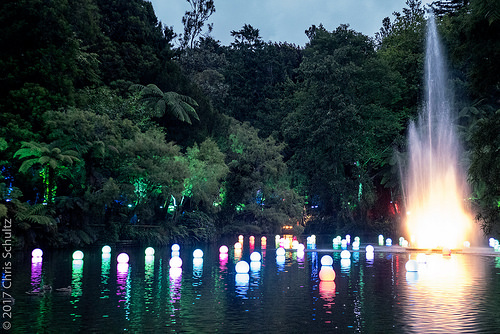<image>
Can you confirm if the light is on the water? Yes. Looking at the image, I can see the light is positioned on top of the water, with the water providing support. Is the lake under the sky? Yes. The lake is positioned underneath the sky, with the sky above it in the vertical space. Is there a lights under the water? No. The lights is not positioned under the water. The vertical relationship between these objects is different. 